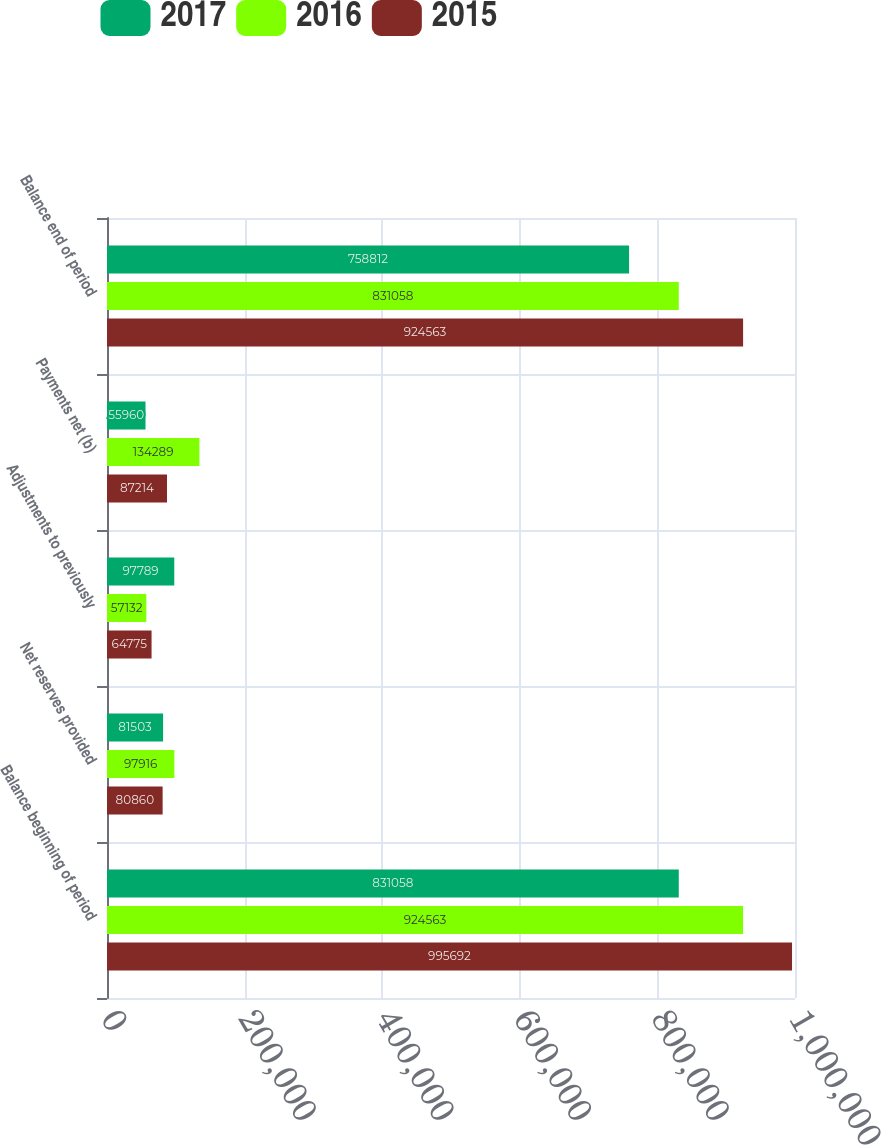Convert chart. <chart><loc_0><loc_0><loc_500><loc_500><stacked_bar_chart><ecel><fcel>Balance beginning of period<fcel>Net reserves provided<fcel>Adjustments to previously<fcel>Payments net (b)<fcel>Balance end of period<nl><fcel>2017<fcel>831058<fcel>81503<fcel>97789<fcel>55960<fcel>758812<nl><fcel>2016<fcel>924563<fcel>97916<fcel>57132<fcel>134289<fcel>831058<nl><fcel>2015<fcel>995692<fcel>80860<fcel>64775<fcel>87214<fcel>924563<nl></chart> 